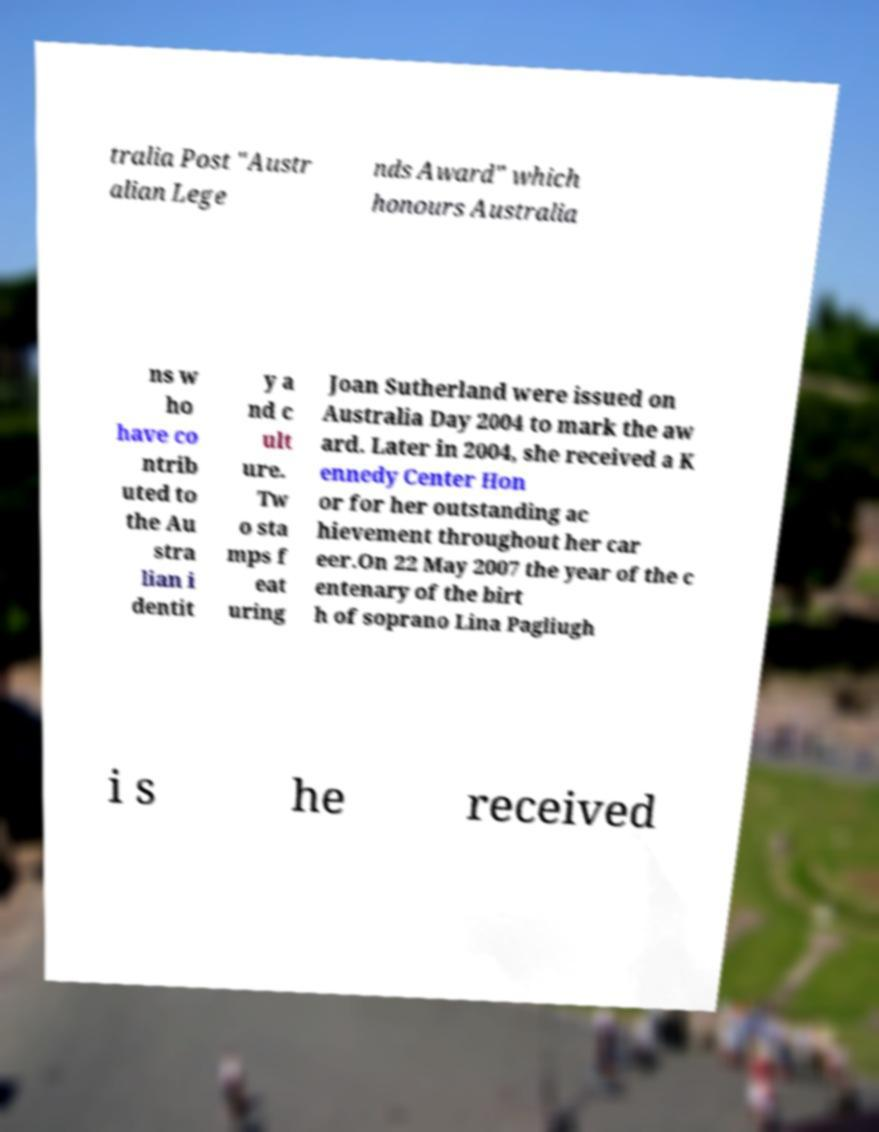I need the written content from this picture converted into text. Can you do that? tralia Post "Austr alian Lege nds Award" which honours Australia ns w ho have co ntrib uted to the Au stra lian i dentit y a nd c ult ure. Tw o sta mps f eat uring Joan Sutherland were issued on Australia Day 2004 to mark the aw ard. Later in 2004, she received a K ennedy Center Hon or for her outstanding ac hievement throughout her car eer.On 22 May 2007 the year of the c entenary of the birt h of soprano Lina Pagliugh i s he received 